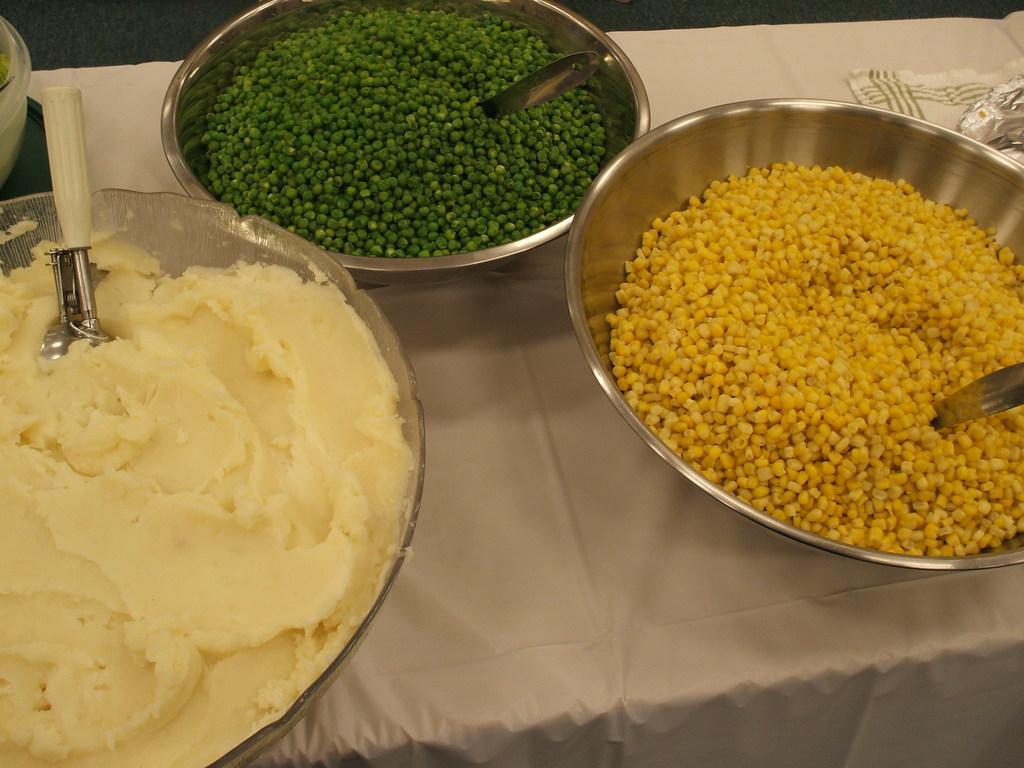Could you give a brief overview of what you see in this image? In the center of the image there is a table on which there are bowls with food items in it. 